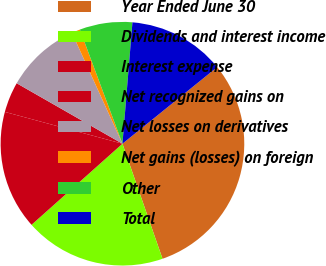Convert chart. <chart><loc_0><loc_0><loc_500><loc_500><pie_chart><fcel>Year Ended June 30<fcel>Dividends and interest income<fcel>Interest expense<fcel>Net recognized gains on<fcel>Net losses on derivatives<fcel>Net gains (losses) on foreign<fcel>Other<fcel>Total<nl><fcel>30.49%<fcel>18.74%<fcel>15.8%<fcel>4.06%<fcel>9.93%<fcel>1.12%<fcel>6.99%<fcel>12.87%<nl></chart> 